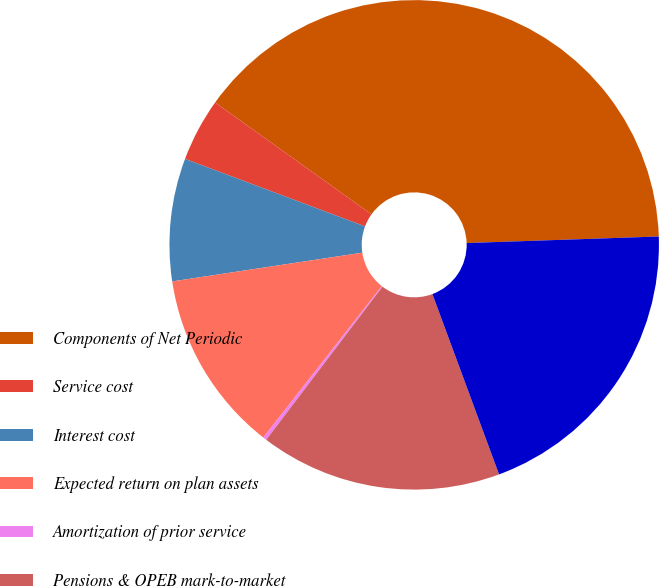<chart> <loc_0><loc_0><loc_500><loc_500><pie_chart><fcel>Components of Net Periodic<fcel>Service cost<fcel>Interest cost<fcel>Expected return on plan assets<fcel>Amortization of prior service<fcel>Pensions & OPEB mark-to-market<fcel>Net periodic cost<nl><fcel>39.58%<fcel>4.17%<fcel>8.1%<fcel>12.04%<fcel>0.24%<fcel>15.97%<fcel>19.91%<nl></chart> 